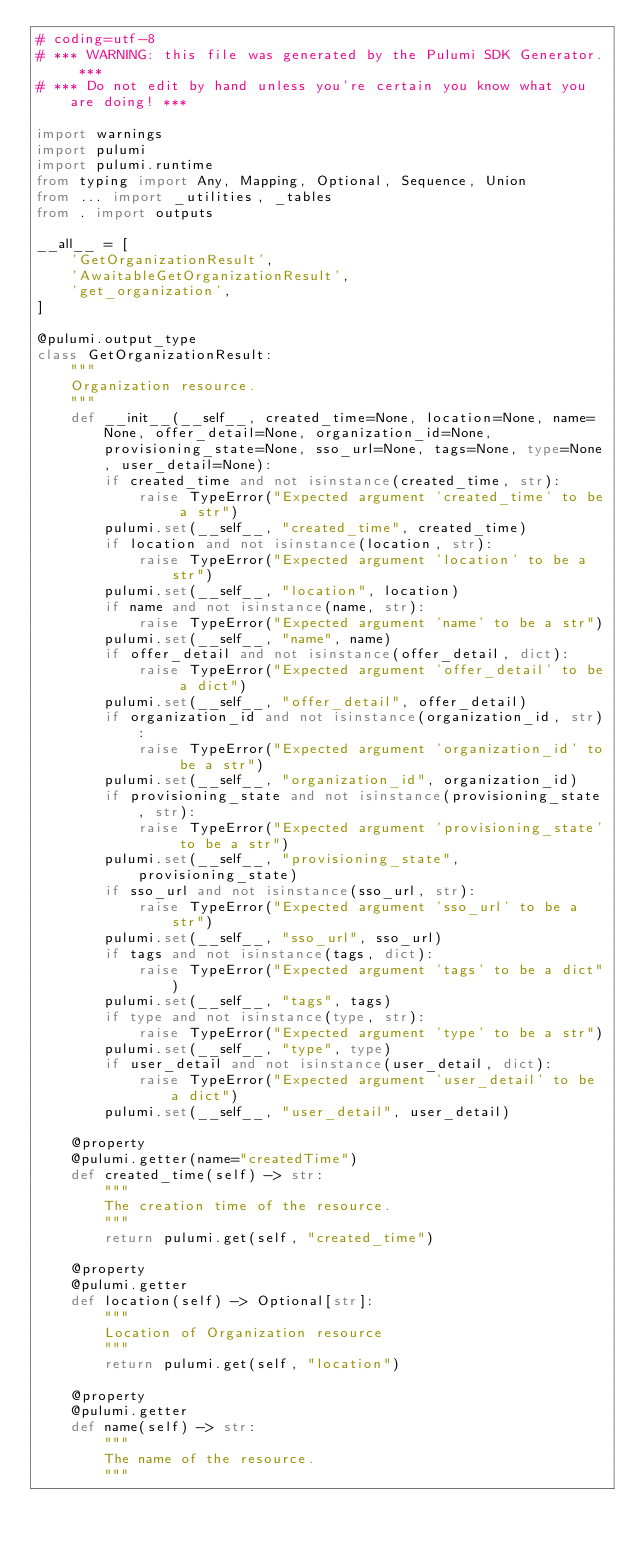<code> <loc_0><loc_0><loc_500><loc_500><_Python_># coding=utf-8
# *** WARNING: this file was generated by the Pulumi SDK Generator. ***
# *** Do not edit by hand unless you're certain you know what you are doing! ***

import warnings
import pulumi
import pulumi.runtime
from typing import Any, Mapping, Optional, Sequence, Union
from ... import _utilities, _tables
from . import outputs

__all__ = [
    'GetOrganizationResult',
    'AwaitableGetOrganizationResult',
    'get_organization',
]

@pulumi.output_type
class GetOrganizationResult:
    """
    Organization resource.
    """
    def __init__(__self__, created_time=None, location=None, name=None, offer_detail=None, organization_id=None, provisioning_state=None, sso_url=None, tags=None, type=None, user_detail=None):
        if created_time and not isinstance(created_time, str):
            raise TypeError("Expected argument 'created_time' to be a str")
        pulumi.set(__self__, "created_time", created_time)
        if location and not isinstance(location, str):
            raise TypeError("Expected argument 'location' to be a str")
        pulumi.set(__self__, "location", location)
        if name and not isinstance(name, str):
            raise TypeError("Expected argument 'name' to be a str")
        pulumi.set(__self__, "name", name)
        if offer_detail and not isinstance(offer_detail, dict):
            raise TypeError("Expected argument 'offer_detail' to be a dict")
        pulumi.set(__self__, "offer_detail", offer_detail)
        if organization_id and not isinstance(organization_id, str):
            raise TypeError("Expected argument 'organization_id' to be a str")
        pulumi.set(__self__, "organization_id", organization_id)
        if provisioning_state and not isinstance(provisioning_state, str):
            raise TypeError("Expected argument 'provisioning_state' to be a str")
        pulumi.set(__self__, "provisioning_state", provisioning_state)
        if sso_url and not isinstance(sso_url, str):
            raise TypeError("Expected argument 'sso_url' to be a str")
        pulumi.set(__self__, "sso_url", sso_url)
        if tags and not isinstance(tags, dict):
            raise TypeError("Expected argument 'tags' to be a dict")
        pulumi.set(__self__, "tags", tags)
        if type and not isinstance(type, str):
            raise TypeError("Expected argument 'type' to be a str")
        pulumi.set(__self__, "type", type)
        if user_detail and not isinstance(user_detail, dict):
            raise TypeError("Expected argument 'user_detail' to be a dict")
        pulumi.set(__self__, "user_detail", user_detail)

    @property
    @pulumi.getter(name="createdTime")
    def created_time(self) -> str:
        """
        The creation time of the resource.
        """
        return pulumi.get(self, "created_time")

    @property
    @pulumi.getter
    def location(self) -> Optional[str]:
        """
        Location of Organization resource
        """
        return pulumi.get(self, "location")

    @property
    @pulumi.getter
    def name(self) -> str:
        """
        The name of the resource.
        """</code> 